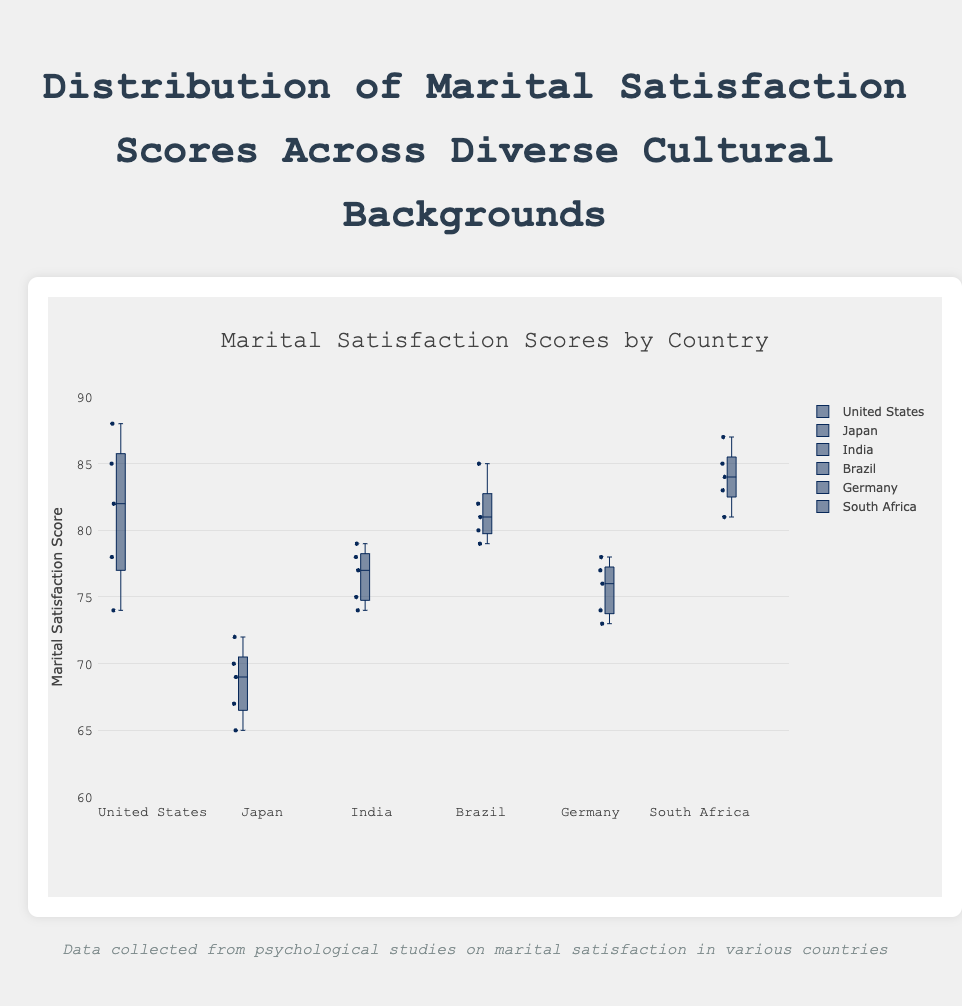What is the title of the figure? The title is located at the top of the figure and reads "Marital Satisfaction Scores by Country".
Answer: Marital Satisfaction Scores by Country Which country shows the highest median marital satisfaction score? The median score is represented by the line inside the box. The country with the highest line inside its box represents the highest median score. In this case, it is South Africa.
Answer: South Africa How does the interquartile range (IQR) of Japan compare to that of the United States? The IQR is the range between the first quartile (bottom of the box) and the third quartile (top of the box). Comparing visually, Japan has a smaller IQR compared to the United States.
Answer: Japan has a smaller IQR Which country has the widest range of marital satisfaction scores? The range of marital satisfaction scores is determined by the distance between the minimum and maximum whiskers. South Africa shows the widest range.
Answer: South Africa What is the overall trend in marital satisfaction scores among the countries presented? By observing the position of the median lines and the spread of the boxes, we can see that most countries (except Japan) have high median marital satisfaction scores and relatively compact distributions.
Answer: High median scores, relatively compact distributions What is the lowest marital satisfaction score recorded in the United States? The minimum score for each country can be identified at the lower whisker. The lowest score for the United States is at 74.
Answer: 74 How does the mean marital satisfaction score of Brazil compare with that of Germany? South Africa's median seems noticeably higher than the others. This comparison requires averaging the data points, but visibly, Brazil's box plot sits higher than Germany’s, implying a higher mean.
Answer: Brazil's mean is higher Which country has the most compact distribution of marital satisfaction scores? Compact distribution means a smaller range between the first and third quartile. Japan has the most compact box, indicating the smallest range.
Answer: Japan Are there any outliers in the data presented for the countries, and if so, which country has them? Outliers are usually represented by individual points outside the whiskers. In this box plot, there are no distinct outliers visible for any country.
Answer: No, there are no outliers What inference can we make about the cultural impact on marital satisfaction based on the visualization? Observing the median and spread, we infer that cultural backgrounds significantly influence marital satisfaction scores, with notable differences in both medians and ranges.
Answer: Significant cultural impact 